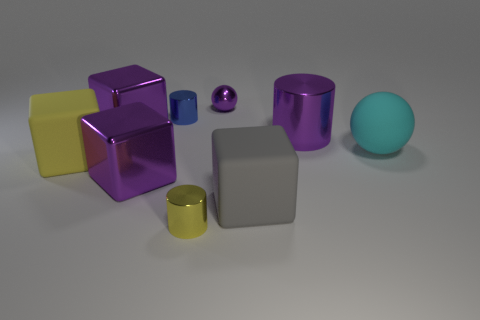Imagine these objects are part of a game, what could be the rules? If these objects were part of a game, one possible rule set could be as follows: Each object has a point value based on its material—metallic objects are worth 5 points, rubber objects 3 points, and plastic objects 1 point. Players take turns rolling the sphere to knock over the cylinders and cubes. The fallen objects are collected by the player, and after all turns, the player with the highest point count wins. This game could test strategy, precision, and a bit of luck. 